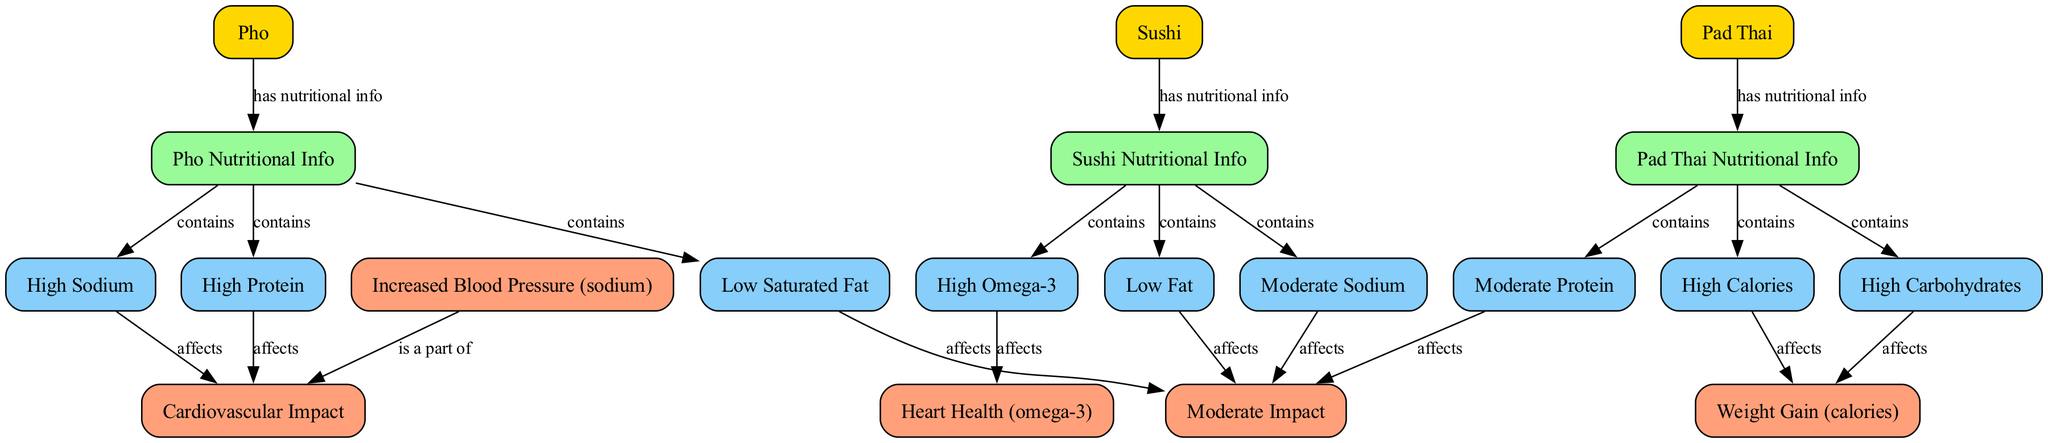What Asian dish has high sodium content? The diagram indicates that Pho is linked to high sodium content in its nutritional info. Therefore, Pho is the dish with high sodium.
Answer: Pho Which Asian dish offers high omega-3 fatty acids? According to the diagram, Sushi has a connection to high omega-3 fatty acids, indicating that this dish is the one enriched with omega-3.
Answer: Sushi How many dishes are represented in the diagram? There are three dishes shown in the diagram: Pho, Sushi, and Pad Thai. By counting the nodes labeled with dish names, we confirm there are three.
Answer: 3 What impact does high protein in Pho have on cardiovascular health? The diagram shows that high protein in Pho affects cardiovascular health, but its specific impact is not severe, as it leads to moderate impact.
Answer: Moderate Impact What type of nutritional info does Pad Thai contain? The diagram specifies that Pad Thai contains high calories, high carbohydrates, and moderate protein. Therefore, the type of nutritional info is indicative of its calorie and carbohydrate content.
Answer: High Calories, High Carbohydrates, Moderate Protein Which dish is associated with increased blood pressure? The diagram connects high sodium content, linked to Pho, directly to increased blood pressure, indicating that Pho is associated with this health concern.
Answer: Pho What overall impact do high carbohydrates in Pad Thai have regarding health? High carbohydrates from Pad Thai lead to weight gain, as expressed in the diagram showing the relationship between high carbohydrates and health impacts, specifically weight gain.
Answer: Weight Gain What is the relationship between low fat Sushi and cardiovascular health? The diagram indicates that low fat in Sushi leads to a moderate impact on cardiovascular health. Therefore, it implies a more favorable effect relative to certain other dishes.
Answer: Moderate Impact How does high calories in Pad Thai affect health? The diagram establishes a direct link from high calories in Pad Thai to weight gain, indicating that the high calorie content has a negative effect on health by promoting weight gain.
Answer: Weight Gain 